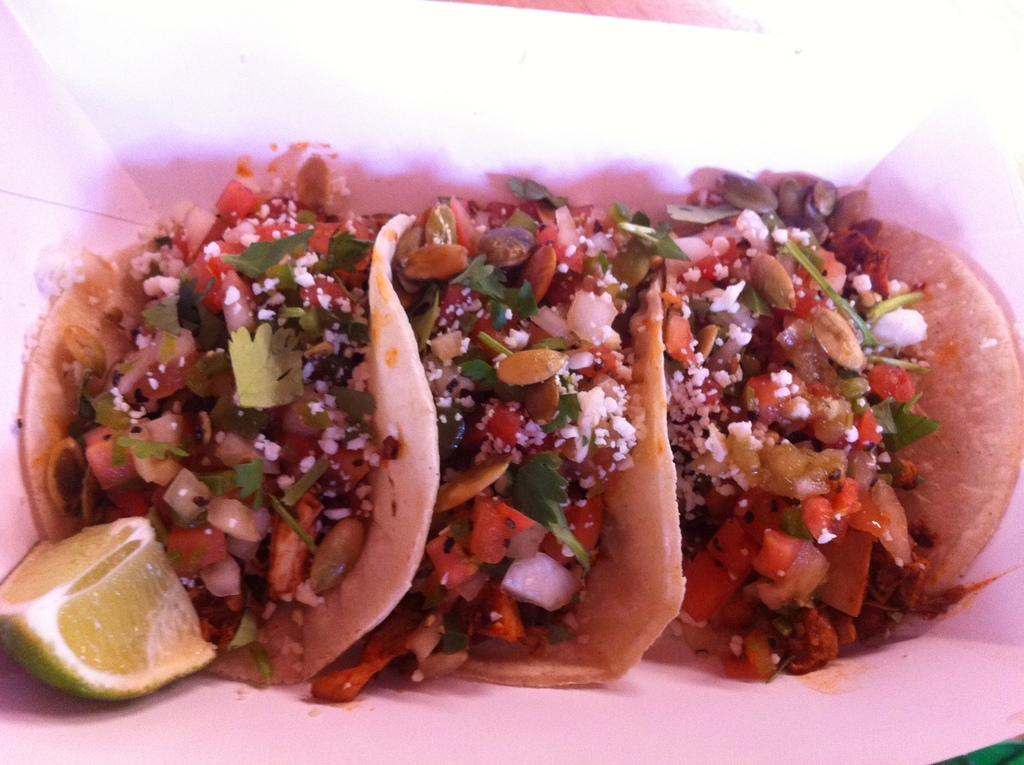What type of food item can be seen in the image? There is a food item in the image, but the specific type cannot be determined from the provided facts. What additional ingredient is present in the image? There is a piece of lemon in the image. What type of honey can be seen drizzled over the fish in the image? There is no honey or fish present in the image; only a food item and a piece of lemon are mentioned. 